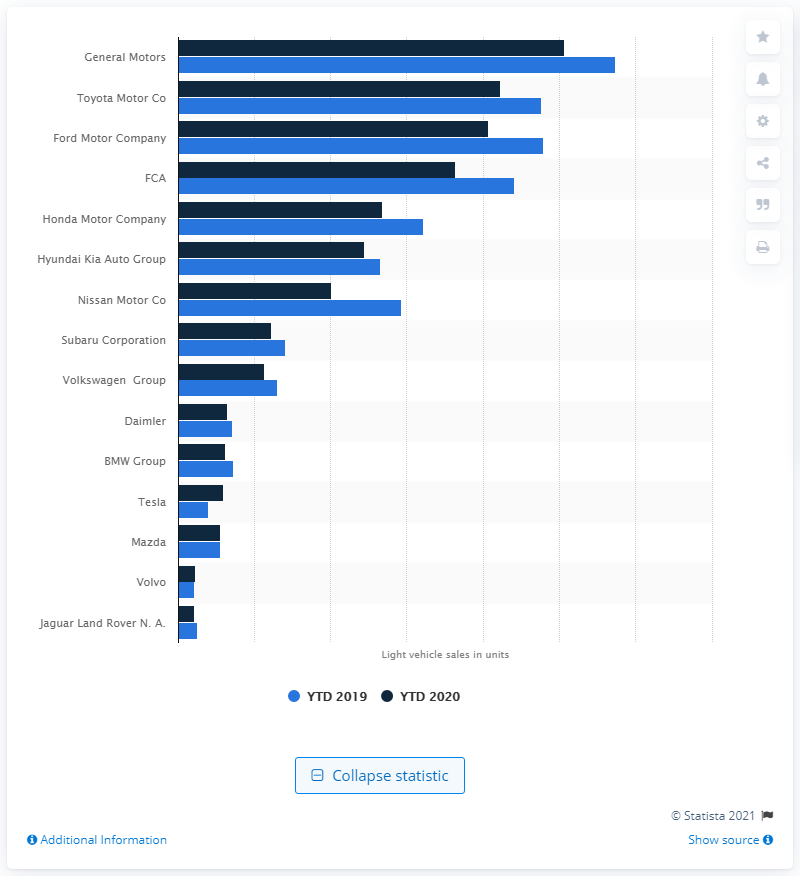Highlight a few significant elements in this photo. In 2020, General Motors was the leading automotive manufacturer from January to December. 